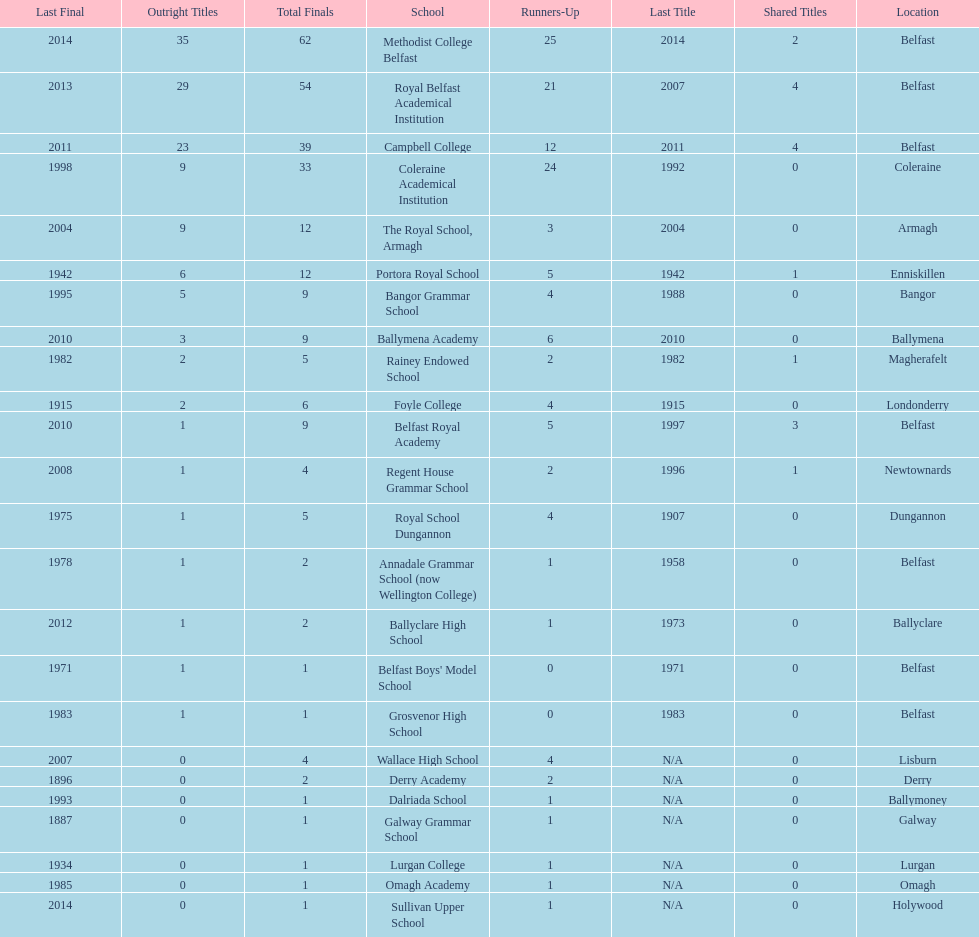Did belfast royal academy have more or less total finals than ballyclare high school? More. 